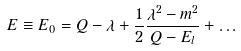<formula> <loc_0><loc_0><loc_500><loc_500>E \equiv E _ { 0 } = Q - \lambda + \frac { 1 } { 2 } \frac { \lambda ^ { 2 } - m ^ { 2 } } { Q - E _ { l } } + \dots</formula> 